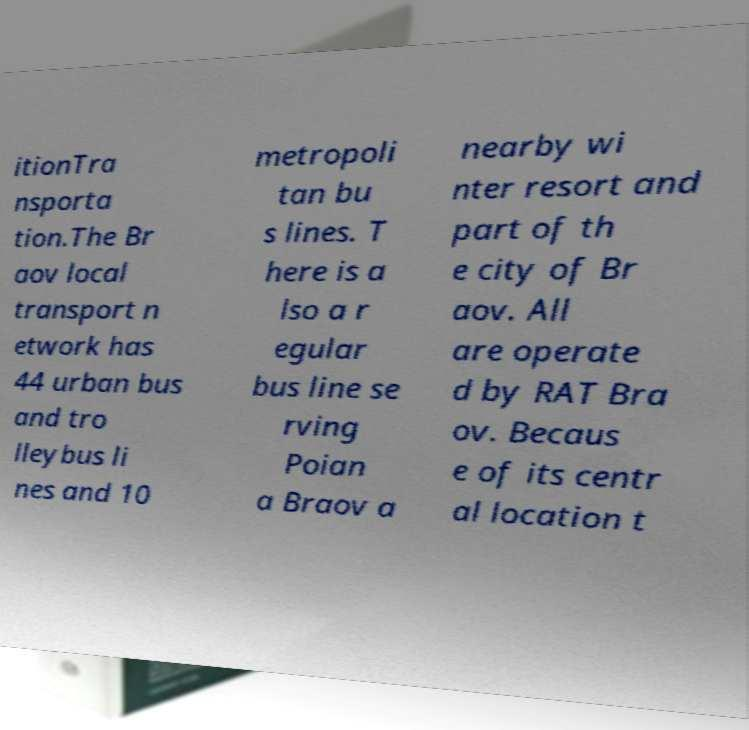Could you assist in decoding the text presented in this image and type it out clearly? itionTra nsporta tion.The Br aov local transport n etwork has 44 urban bus and tro lleybus li nes and 10 metropoli tan bu s lines. T here is a lso a r egular bus line se rving Poian a Braov a nearby wi nter resort and part of th e city of Br aov. All are operate d by RAT Bra ov. Becaus e of its centr al location t 